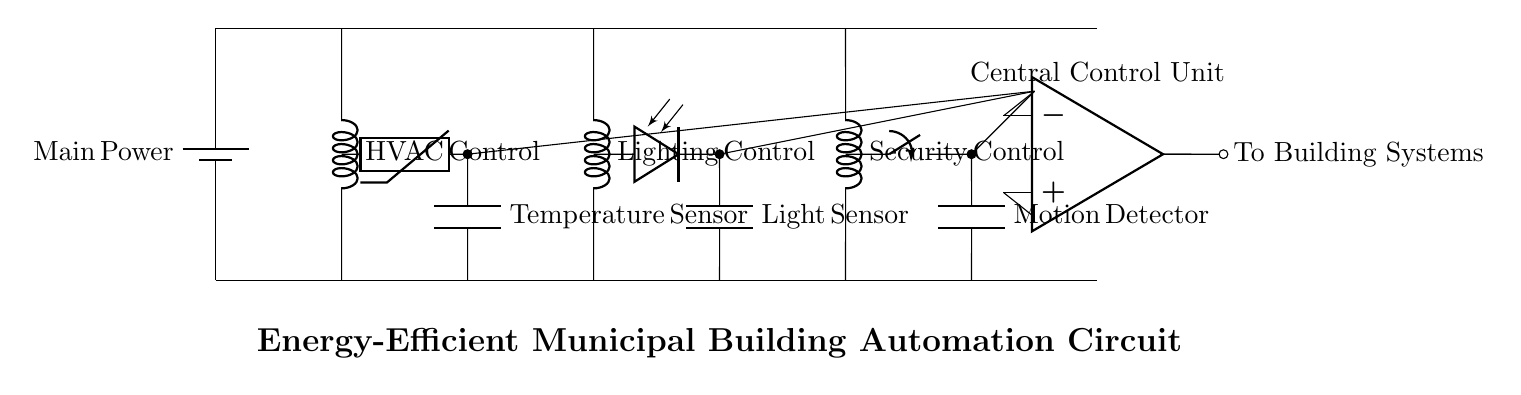What type of circuit is represented? The circuit is an automation circuit integrating HVAC, lighting, and security systems, as indicated by the labeled components for each system.
Answer: Energy-efficient municipal building automation circuit How many control systems are included? There are three main control systems visible in the circuit: HVAC Control, Lighting Control, and Security Control. Each is specifically labeled and integrates with the central control unit.
Answer: Three What is the role of the thermistor? The thermistor is used as a sensor that detects temperature changes, which is crucial for the HVAC system's control, as indicated by its connection to the HVAC Control.
Answer: Temperature sensing Which component detects motion? The component that detects motion is the motion detector, which is connected to the Security Control in the circuit, indicating its role in the security system.
Answer: Motion detector How is the central control unit powered? The central control unit is powered through connections from the main power supply, which shows that it receives voltage from the battery supply at the top of the circuit diagram.
Answer: Main power supply What type of sensor is used for lighting? The circuit uses a photodiode as a sensor for detecting light levels, which is an integral part of the Lighting Control system, as depicted in the diagram.
Answer: Photodiode What signifies the connection of the building systems? The connection to building systems is signified by the shorting conductor at the output of the central control unit, which leads to "To Building Systems," showing that it coordinates the automation functions.
Answer: To Building Systems 